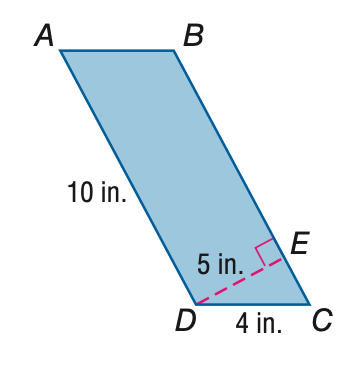Answer the mathemtical geometry problem and directly provide the correct option letter.
Question: Find the area of \parallelogram A B C D.
Choices: A: 30 B: 40 C: 50 D: 60 C 